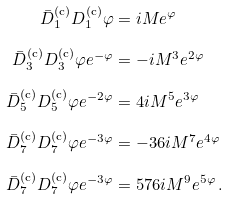Convert formula to latex. <formula><loc_0><loc_0><loc_500><loc_500>\bar { D } _ { 1 } ^ { \text {(c)} } D _ { 1 } ^ { \text {(c)} } \varphi & = i M e ^ { \varphi } \\ \bar { D } _ { 3 } ^ { \text {(c)} } D _ { 3 } ^ { \text {(c)} } \varphi e ^ { - \varphi } & = - i M ^ { 3 } e ^ { 2 \varphi } \\ \bar { D } _ { 5 } ^ { \text {(c)} } D _ { 5 } ^ { \text {(c)} } \varphi e ^ { - 2 \varphi } & = 4 i M ^ { 5 } e ^ { 3 \varphi } \\ \bar { D } _ { 7 } ^ { \text {(c)} } D _ { 7 } ^ { \text {(c)} } \varphi e ^ { - 3 \varphi } & = - 3 6 i M ^ { 7 } e ^ { 4 \varphi } \, \\ \bar { D } _ { 7 } ^ { \text {(c)} } D _ { 7 } ^ { \text {(c)} } \varphi e ^ { - 3 \varphi } & = 5 7 6 i M ^ { 9 } e ^ { 5 \varphi } \, .</formula> 